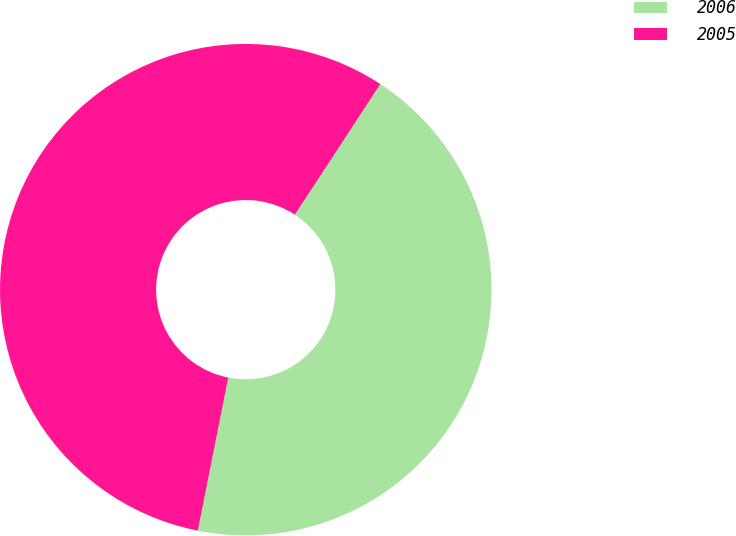<chart> <loc_0><loc_0><loc_500><loc_500><pie_chart><fcel>2006<fcel>2005<nl><fcel>43.9%<fcel>56.1%<nl></chart> 